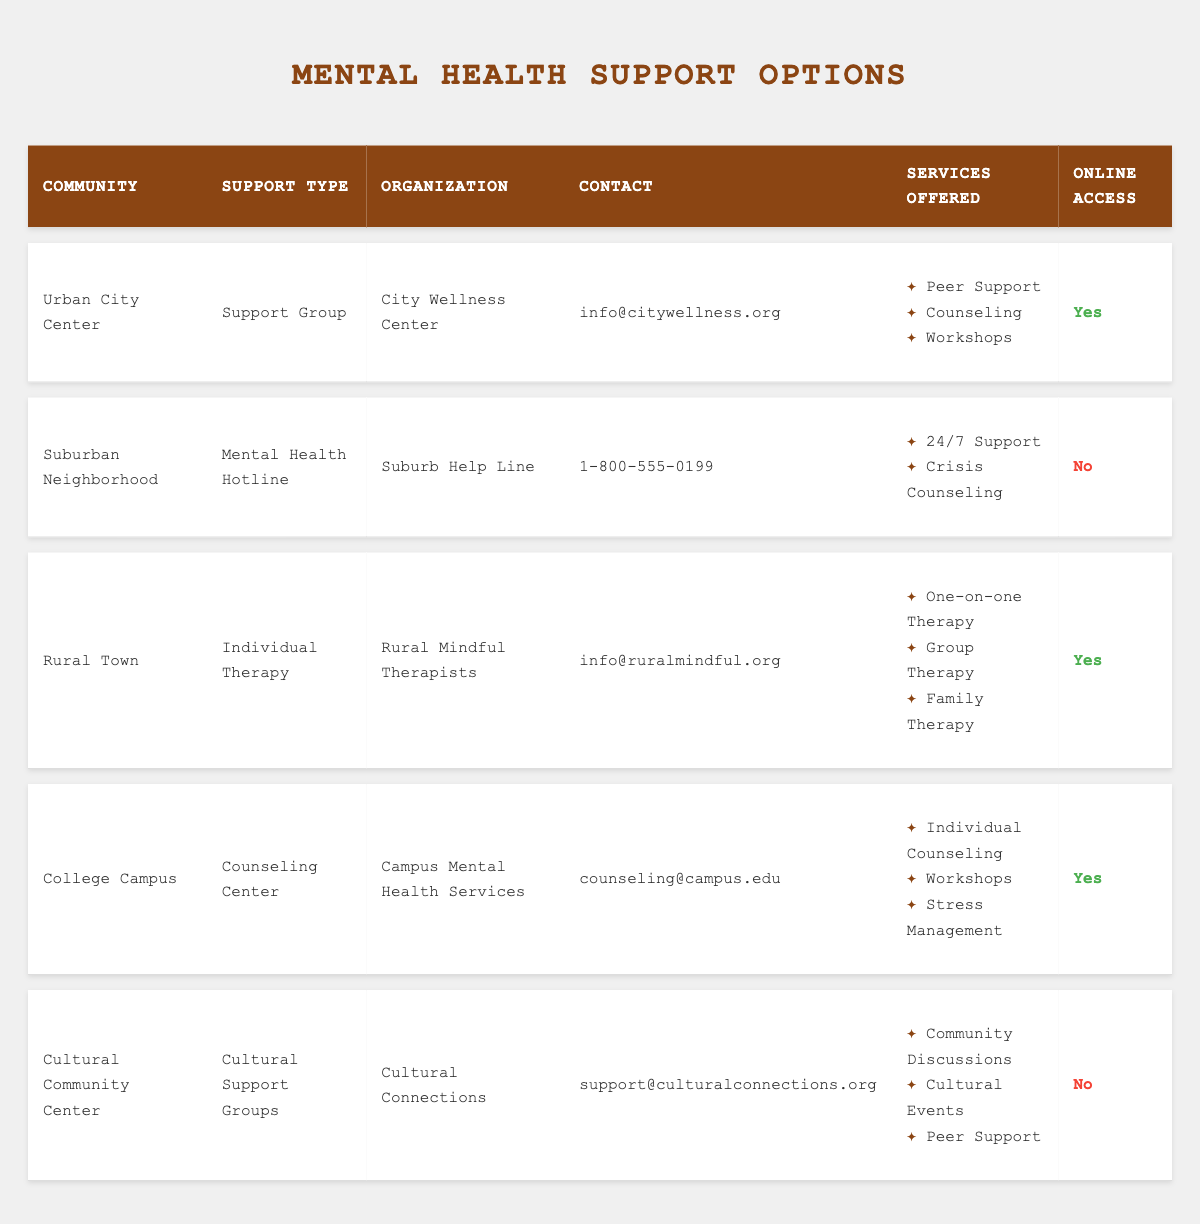What type of support does the "City Wellness Center" provide? The "City Wellness Center" is listed under the "Urban City Center" community and offers a "Support Group" as the support type. The services offered include Peer Support, Counseling, and Workshops.
Answer: Support Group Which community offers a 24/7 support service? The "Suburban Neighborhood" community provides this service through the "Suburb Help Line," which is categorized as a "Mental Health Hotline," offering 24/7 support and crisis counseling.
Answer: Suburban Neighborhood How many communities offer online access to their support services? By reviewing the table, we find that the "Urban City Center," "Rural Town," and "College Campus" communities offer online access, totaling three communities with this feature.
Answer: Three Does the "Cultural Connections" organization provide online access? The "Cultural Connections" organization, located at the "Cultural Community Center," has its row marked "No" for online access, indicating they do not provide this feature.
Answer: No What services are offered under the "Campus Mental Health Services"? "Campus Mental Health Services" located at the "College Campus" offers Individual Counseling, Workshops, and Stress Management as its services. These are directly listed in the table under services offered.
Answer: Individual Counseling, Workshops, Stress Management Which community has both individual and family therapy available? The "Rural Town" community, through "Rural Mindful Therapists," offers both One-on-one Therapy and Family Therapy listed under the services offered.
Answer: Rural Town Are there any communities that do not provide online access? Yes, both the "Suburban Neighborhood" and "Cultural Community Center" do not provide online access according to the table.
Answer: Yes What is the contact information for the "Cultural Connections"? The contact information listed for "Cultural Connections" in the "Cultural Community Center" is support@culturalconnections.org.
Answer: support@culturalconnections.org Which community provides group therapy alongside individual therapy? The "Rural Town" community provides both One-on-one Therapy and Group Therapy as part of the services offered by "Rural Mindful Therapists."
Answer: Rural Town 